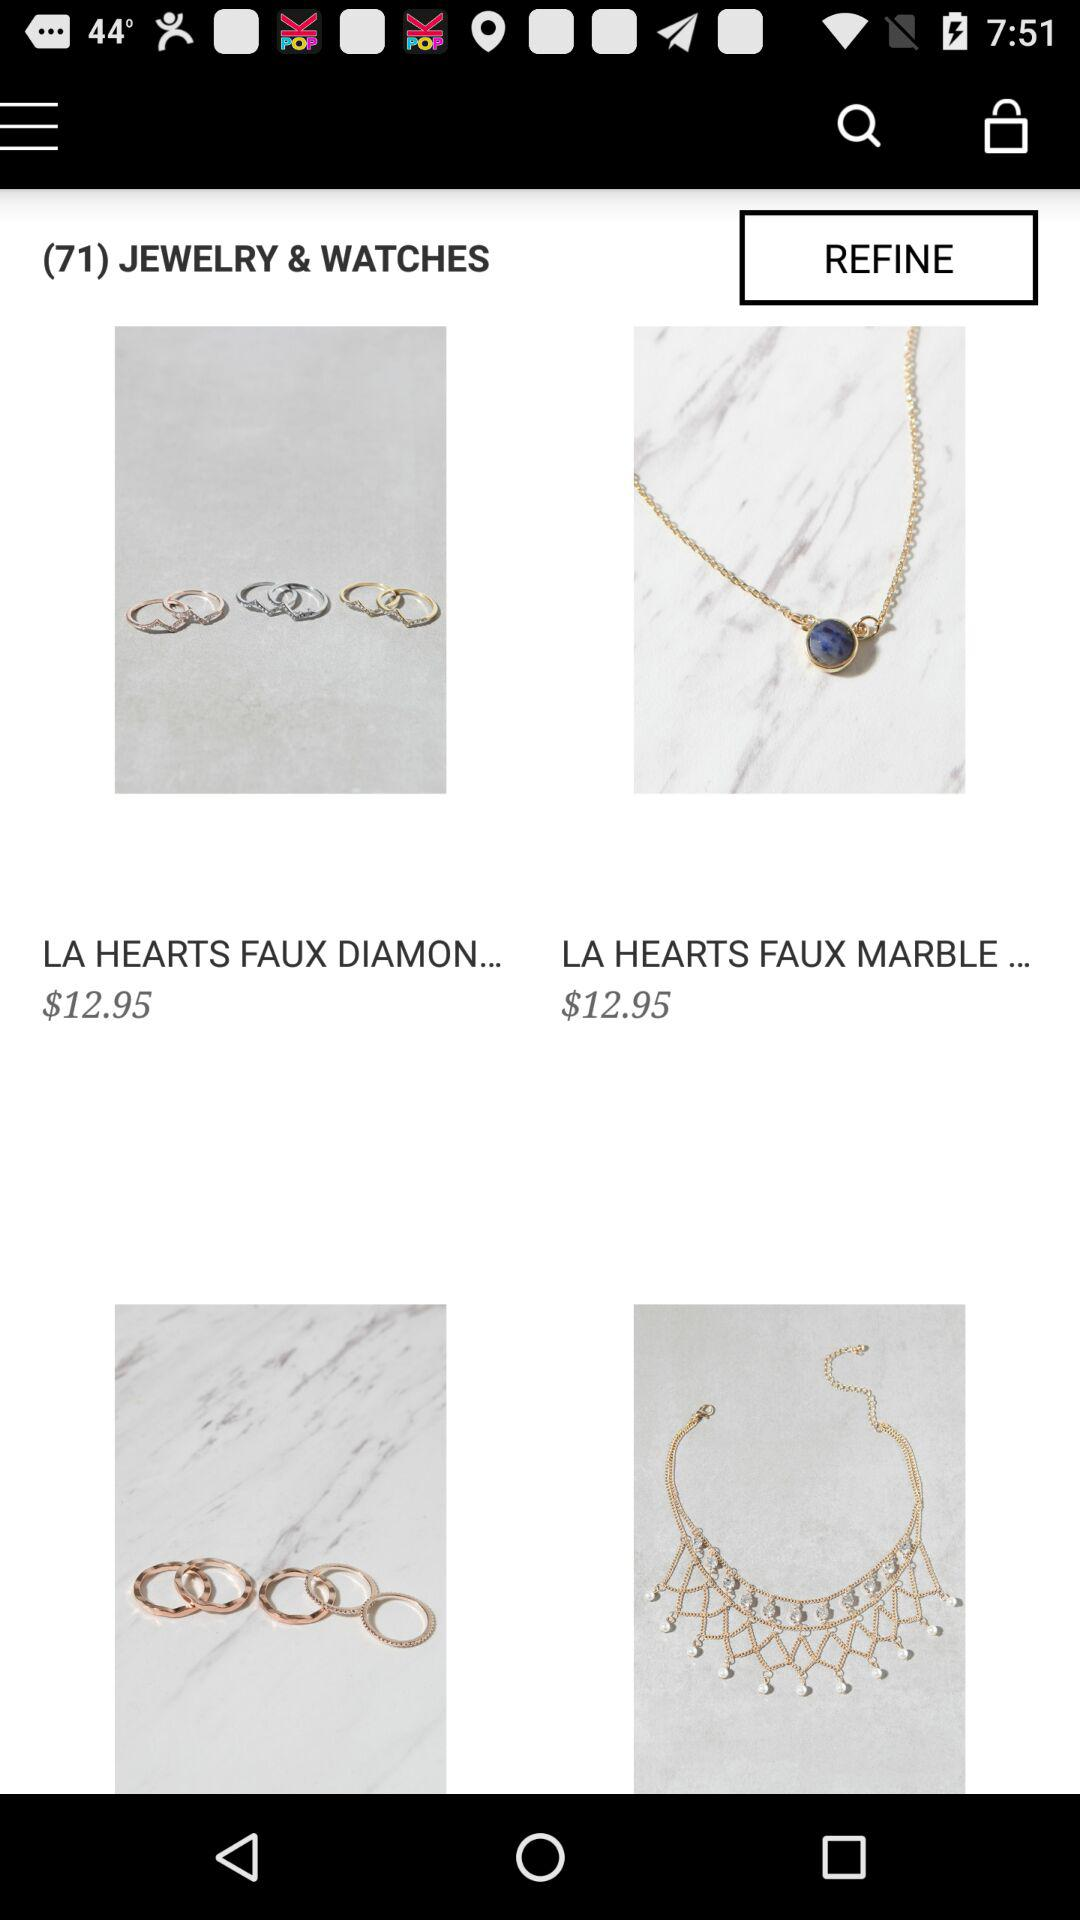What is the price of "LA HEARTS FAUX MARBLE..."? The price of "LA HEARTS FAUX MARBLE..." is $12.95. 